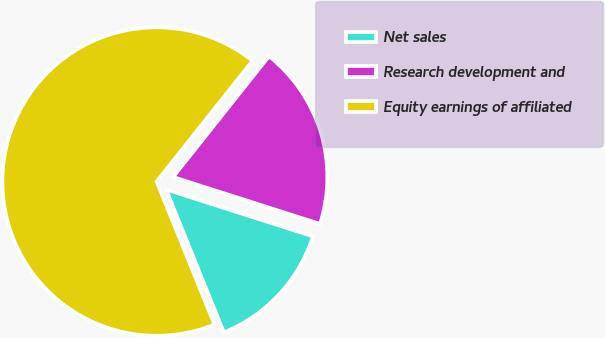Convert chart to OTSL. <chart><loc_0><loc_0><loc_500><loc_500><pie_chart><fcel>Net sales<fcel>Research development and<fcel>Equity earnings of affiliated<nl><fcel>13.96%<fcel>19.24%<fcel>66.8%<nl></chart> 